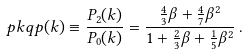<formula> <loc_0><loc_0><loc_500><loc_500>\ p k q p ( k ) \equiv \frac { P _ { 2 } ( k ) } { P _ { 0 } ( k ) } = \frac { \frac { 4 } { 3 } \beta + \frac { 4 } { 7 } \beta ^ { 2 } } { 1 + \frac { 2 } { 3 } \beta + \frac { 1 } { 5 } \beta ^ { 2 } } \, .</formula> 